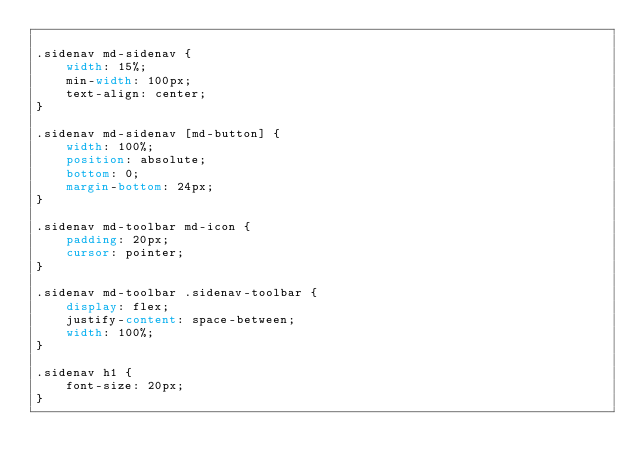Convert code to text. <code><loc_0><loc_0><loc_500><loc_500><_CSS_>
.sidenav md-sidenav {
    width: 15%;
    min-width: 100px;
    text-align: center;
}

.sidenav md-sidenav [md-button] {
    width: 100%;
    position: absolute;
    bottom: 0;
    margin-bottom: 24px;
}

.sidenav md-toolbar md-icon {
    padding: 20px;
    cursor: pointer;
}

.sidenav md-toolbar .sidenav-toolbar {
    display: flex;
    justify-content: space-between;
    width: 100%;
}

.sidenav h1 {
    font-size: 20px;
}
</code> 